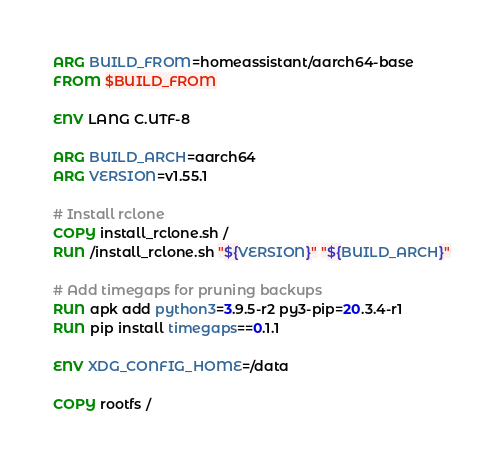<code> <loc_0><loc_0><loc_500><loc_500><_Dockerfile_>ARG BUILD_FROM=homeassistant/aarch64-base
FROM $BUILD_FROM

ENV LANG C.UTF-8

ARG BUILD_ARCH=aarch64
ARG VERSION=v1.55.1

# Install rclone
COPY install_rclone.sh /
RUN /install_rclone.sh "${VERSION}" "${BUILD_ARCH}"

# Add timegaps for pruning backups
RUN apk add python3=3.9.5-r2 py3-pip=20.3.4-r1
RUN pip install timegaps==0.1.1

ENV XDG_CONFIG_HOME=/data

COPY rootfs /
</code> 